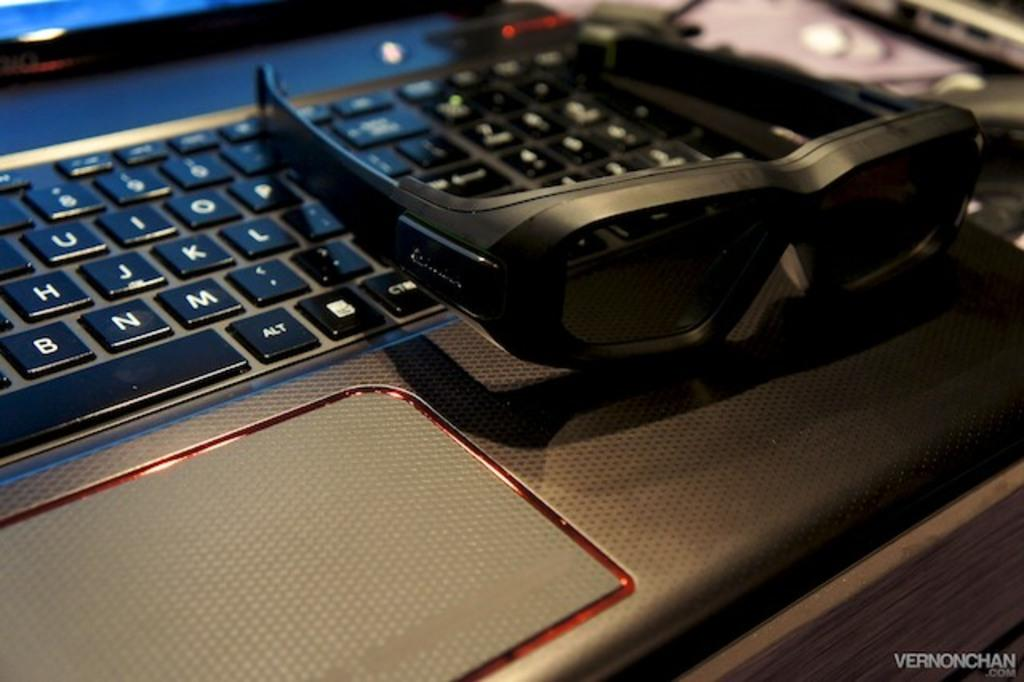<image>
Write a terse but informative summary of the picture. A computer keyboard has the B key right next to the N key. 